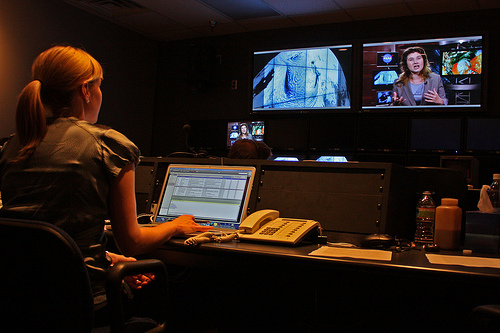How many women watching the TV? 1 